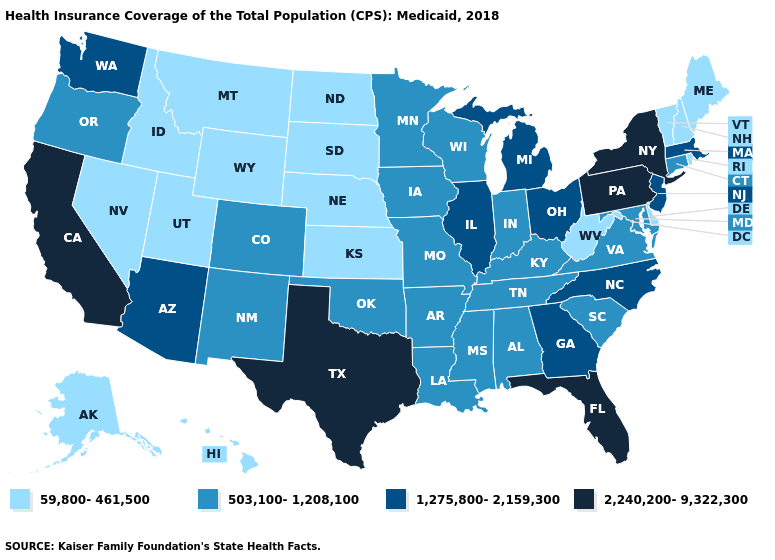Name the states that have a value in the range 503,100-1,208,100?
Keep it brief. Alabama, Arkansas, Colorado, Connecticut, Indiana, Iowa, Kentucky, Louisiana, Maryland, Minnesota, Mississippi, Missouri, New Mexico, Oklahoma, Oregon, South Carolina, Tennessee, Virginia, Wisconsin. Does Hawaii have the highest value in the USA?
Short answer required. No. What is the highest value in the USA?
Keep it brief. 2,240,200-9,322,300. Name the states that have a value in the range 2,240,200-9,322,300?
Be succinct. California, Florida, New York, Pennsylvania, Texas. Does the first symbol in the legend represent the smallest category?
Answer briefly. Yes. Among the states that border Wisconsin , does Iowa have the lowest value?
Keep it brief. Yes. What is the lowest value in the West?
Be succinct. 59,800-461,500. What is the value of Arkansas?
Concise answer only. 503,100-1,208,100. Which states have the lowest value in the USA?
Keep it brief. Alaska, Delaware, Hawaii, Idaho, Kansas, Maine, Montana, Nebraska, Nevada, New Hampshire, North Dakota, Rhode Island, South Dakota, Utah, Vermont, West Virginia, Wyoming. Does Connecticut have the lowest value in the USA?
Give a very brief answer. No. What is the value of New Jersey?
Concise answer only. 1,275,800-2,159,300. What is the value of South Carolina?
Short answer required. 503,100-1,208,100. Does North Carolina have the lowest value in the USA?
Quick response, please. No. What is the value of Oregon?
Short answer required. 503,100-1,208,100. Does Wisconsin have the lowest value in the MidWest?
Short answer required. No. 